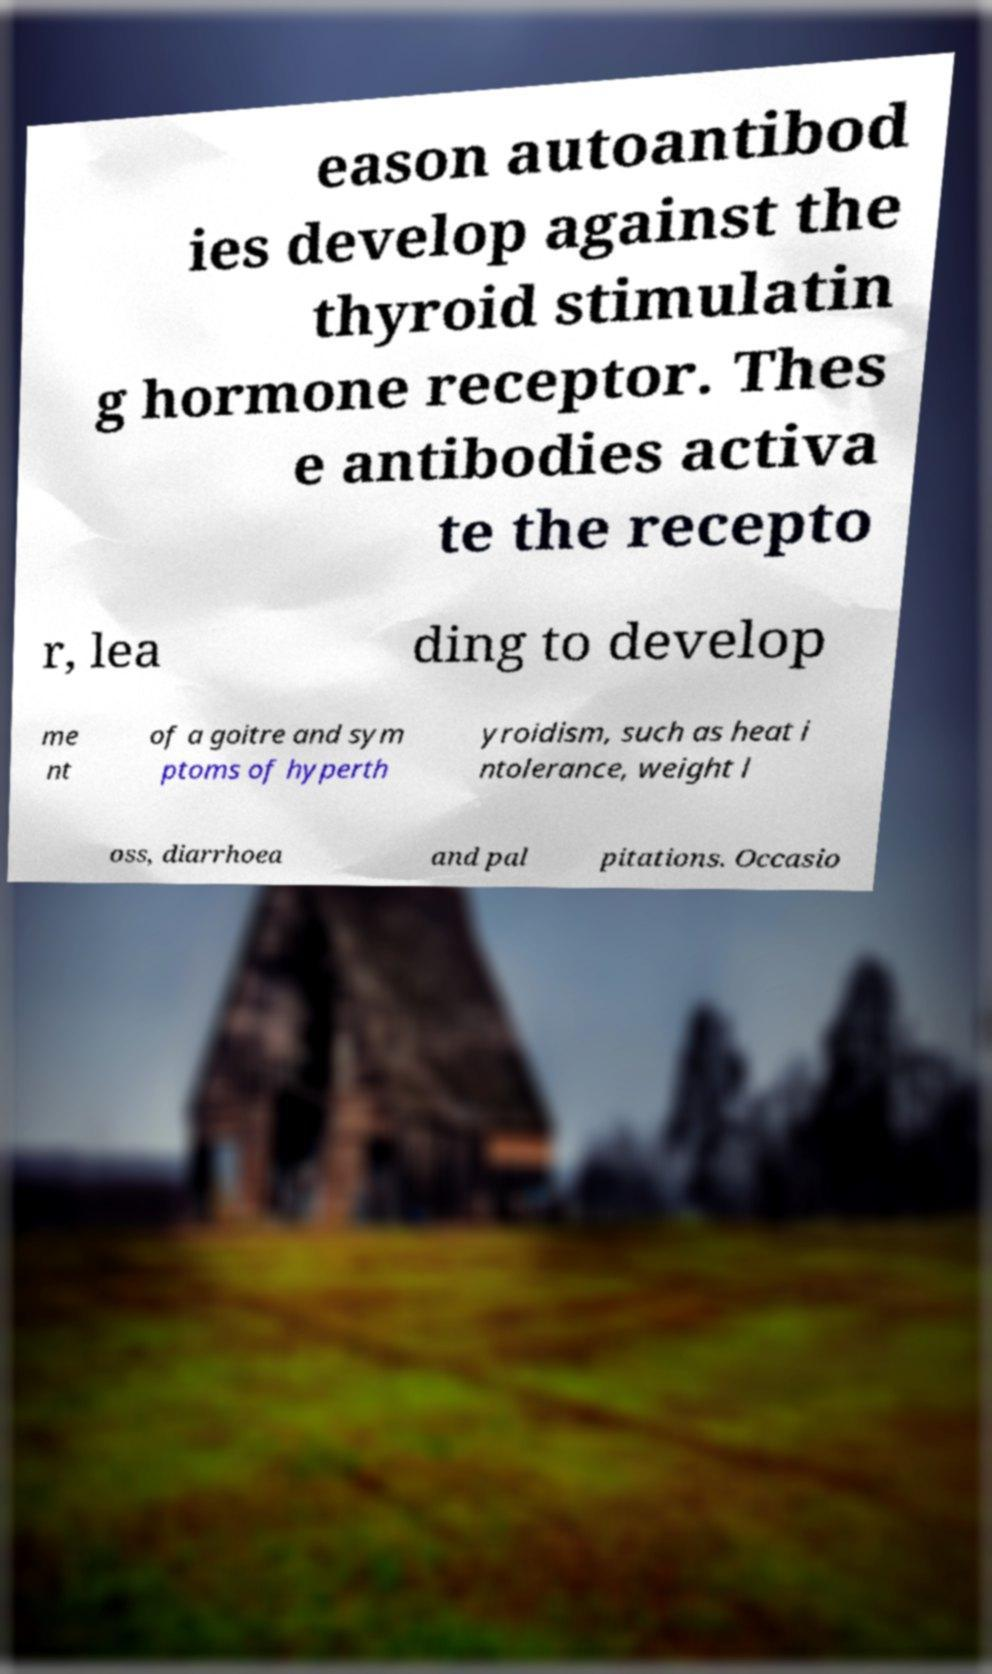I need the written content from this picture converted into text. Can you do that? eason autoantibod ies develop against the thyroid stimulatin g hormone receptor. Thes e antibodies activa te the recepto r, lea ding to develop me nt of a goitre and sym ptoms of hyperth yroidism, such as heat i ntolerance, weight l oss, diarrhoea and pal pitations. Occasio 